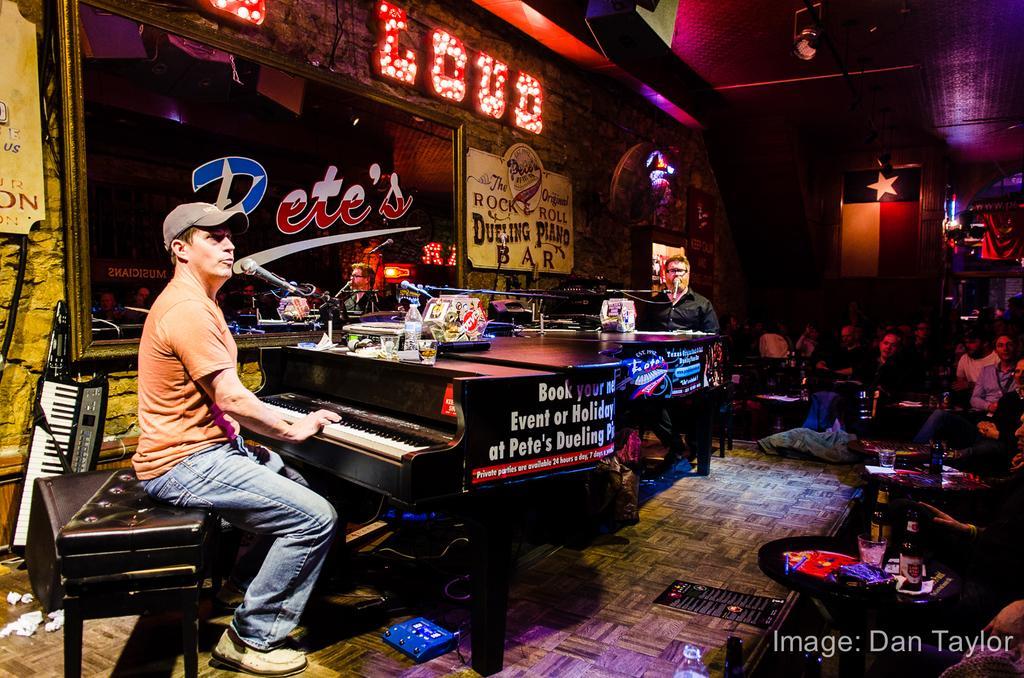Could you give a brief overview of what you see in this image? In this image there are group of people. The person with peach color t-shirt is sitting and playing musical instrument and there are bottles, glass on the table. At the back there is a screen , at the top there is a light. 